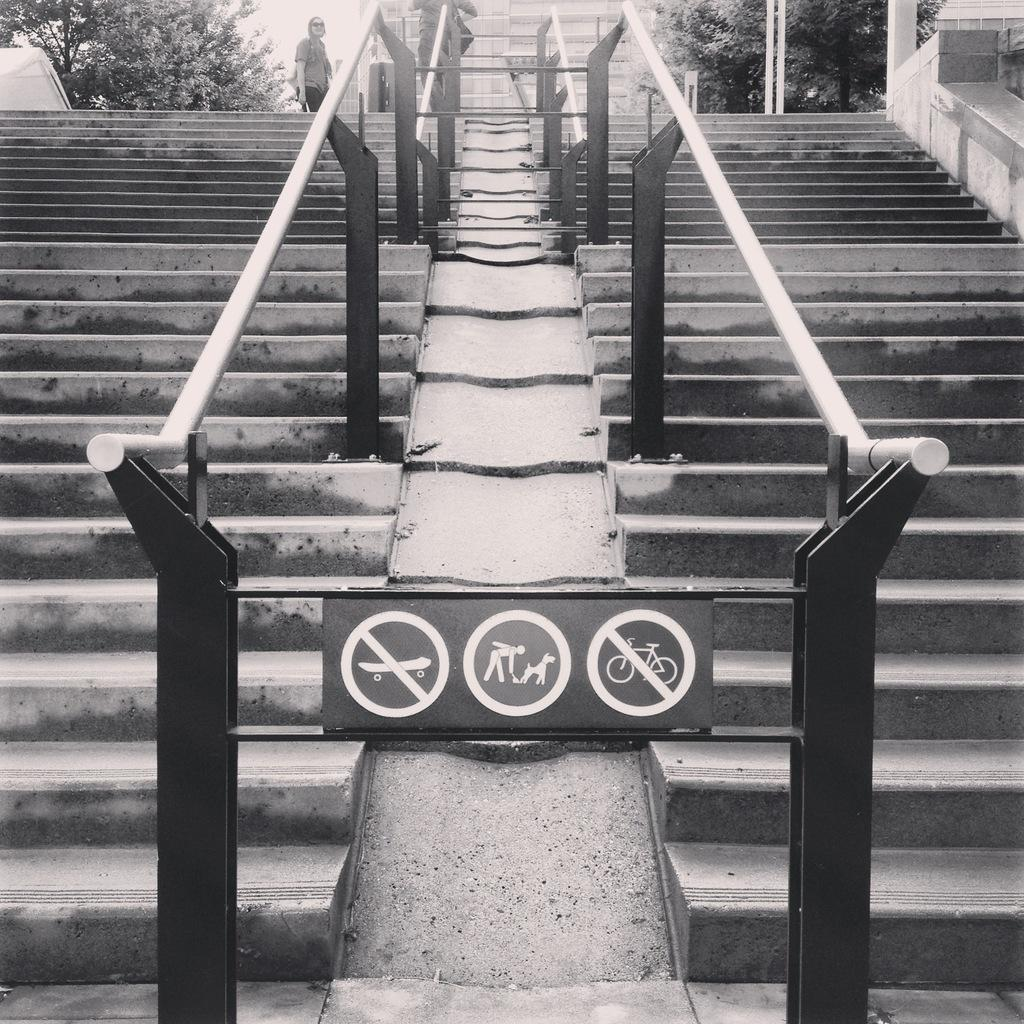What is the main object in the center of the image? There is a board in the center of the image. What architectural feature can be seen in the image? There are stairs in the image. What type of barrier is present in the image? There is a metal fence in the image. Can you describe the background of the image? There is a person, trees, and buildings in the background of the image. What type of drain is visible in the image? There is no drain present in the image. Who is the writer in the image? There is no writer depicted in the image. 